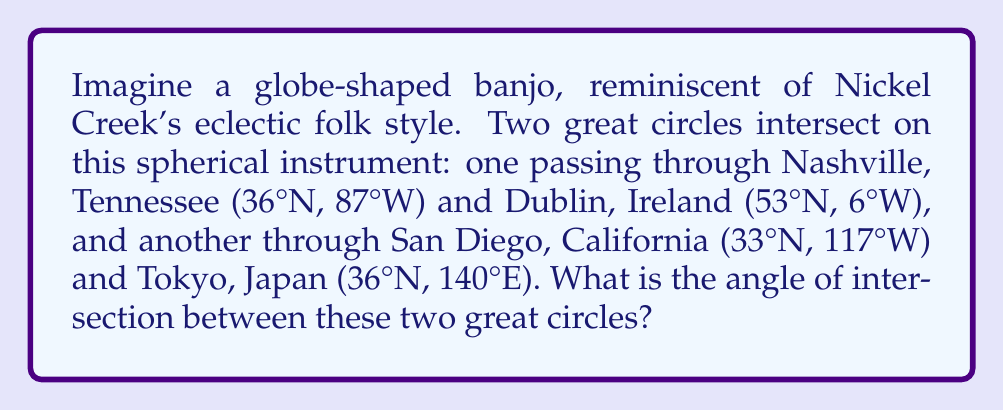Help me with this question. To solve this problem, we'll use spherical trigonometry:

1) First, we need to convert the given coordinates to radians:
   Nashville: (0.628, -1.518)
   Dublin: (0.925, -0.105)
   San Diego: (0.576, -2.042)
   Tokyo: (0.628, 2.443)

2) Calculate the normal vectors to each great circle plane:
   For Nashville-Dublin (ND):
   $$\vec{n_{ND}} = \begin{pmatrix}\cos(0.628)\sin(-1.518) \\ \sin(0.628) \\ \cos(0.628)\cos(-1.518)\end{pmatrix} \times \begin{pmatrix}\cos(0.925)\sin(-0.105) \\ \sin(0.925) \\ \cos(0.925)\cos(-0.105)\end{pmatrix}$$

   For San Diego-Tokyo (ST):
   $$\vec{n_{ST}} = \begin{pmatrix}\cos(0.576)\sin(-2.042) \\ \sin(0.576) \\ \cos(0.576)\cos(-2.042)\end{pmatrix} \times \begin{pmatrix}\cos(0.628)\sin(2.443) \\ \sin(0.628) \\ \cos(0.628)\cos(2.443)\end{pmatrix}$$

3) Calculate the dot product of these normal vectors:
   $$\cos(\theta) = \frac{\vec{n_{ND}} \cdot \vec{n_{ST}}}{|\vec{n_{ND}}||\vec{n_{ST}}|}$$

4) The angle of intersection is then:
   $$\theta = \arccos(\cos(\theta))$$

5) Performing these calculations (which involve extensive matrix operations) yields:
   $$\theta \approx 1.839 \text{ radians}$$

6) Convert to degrees:
   $$1.839 \text{ radians} \times \frac{180°}{\pi} \approx 105.4°$$
Answer: 105.4° 